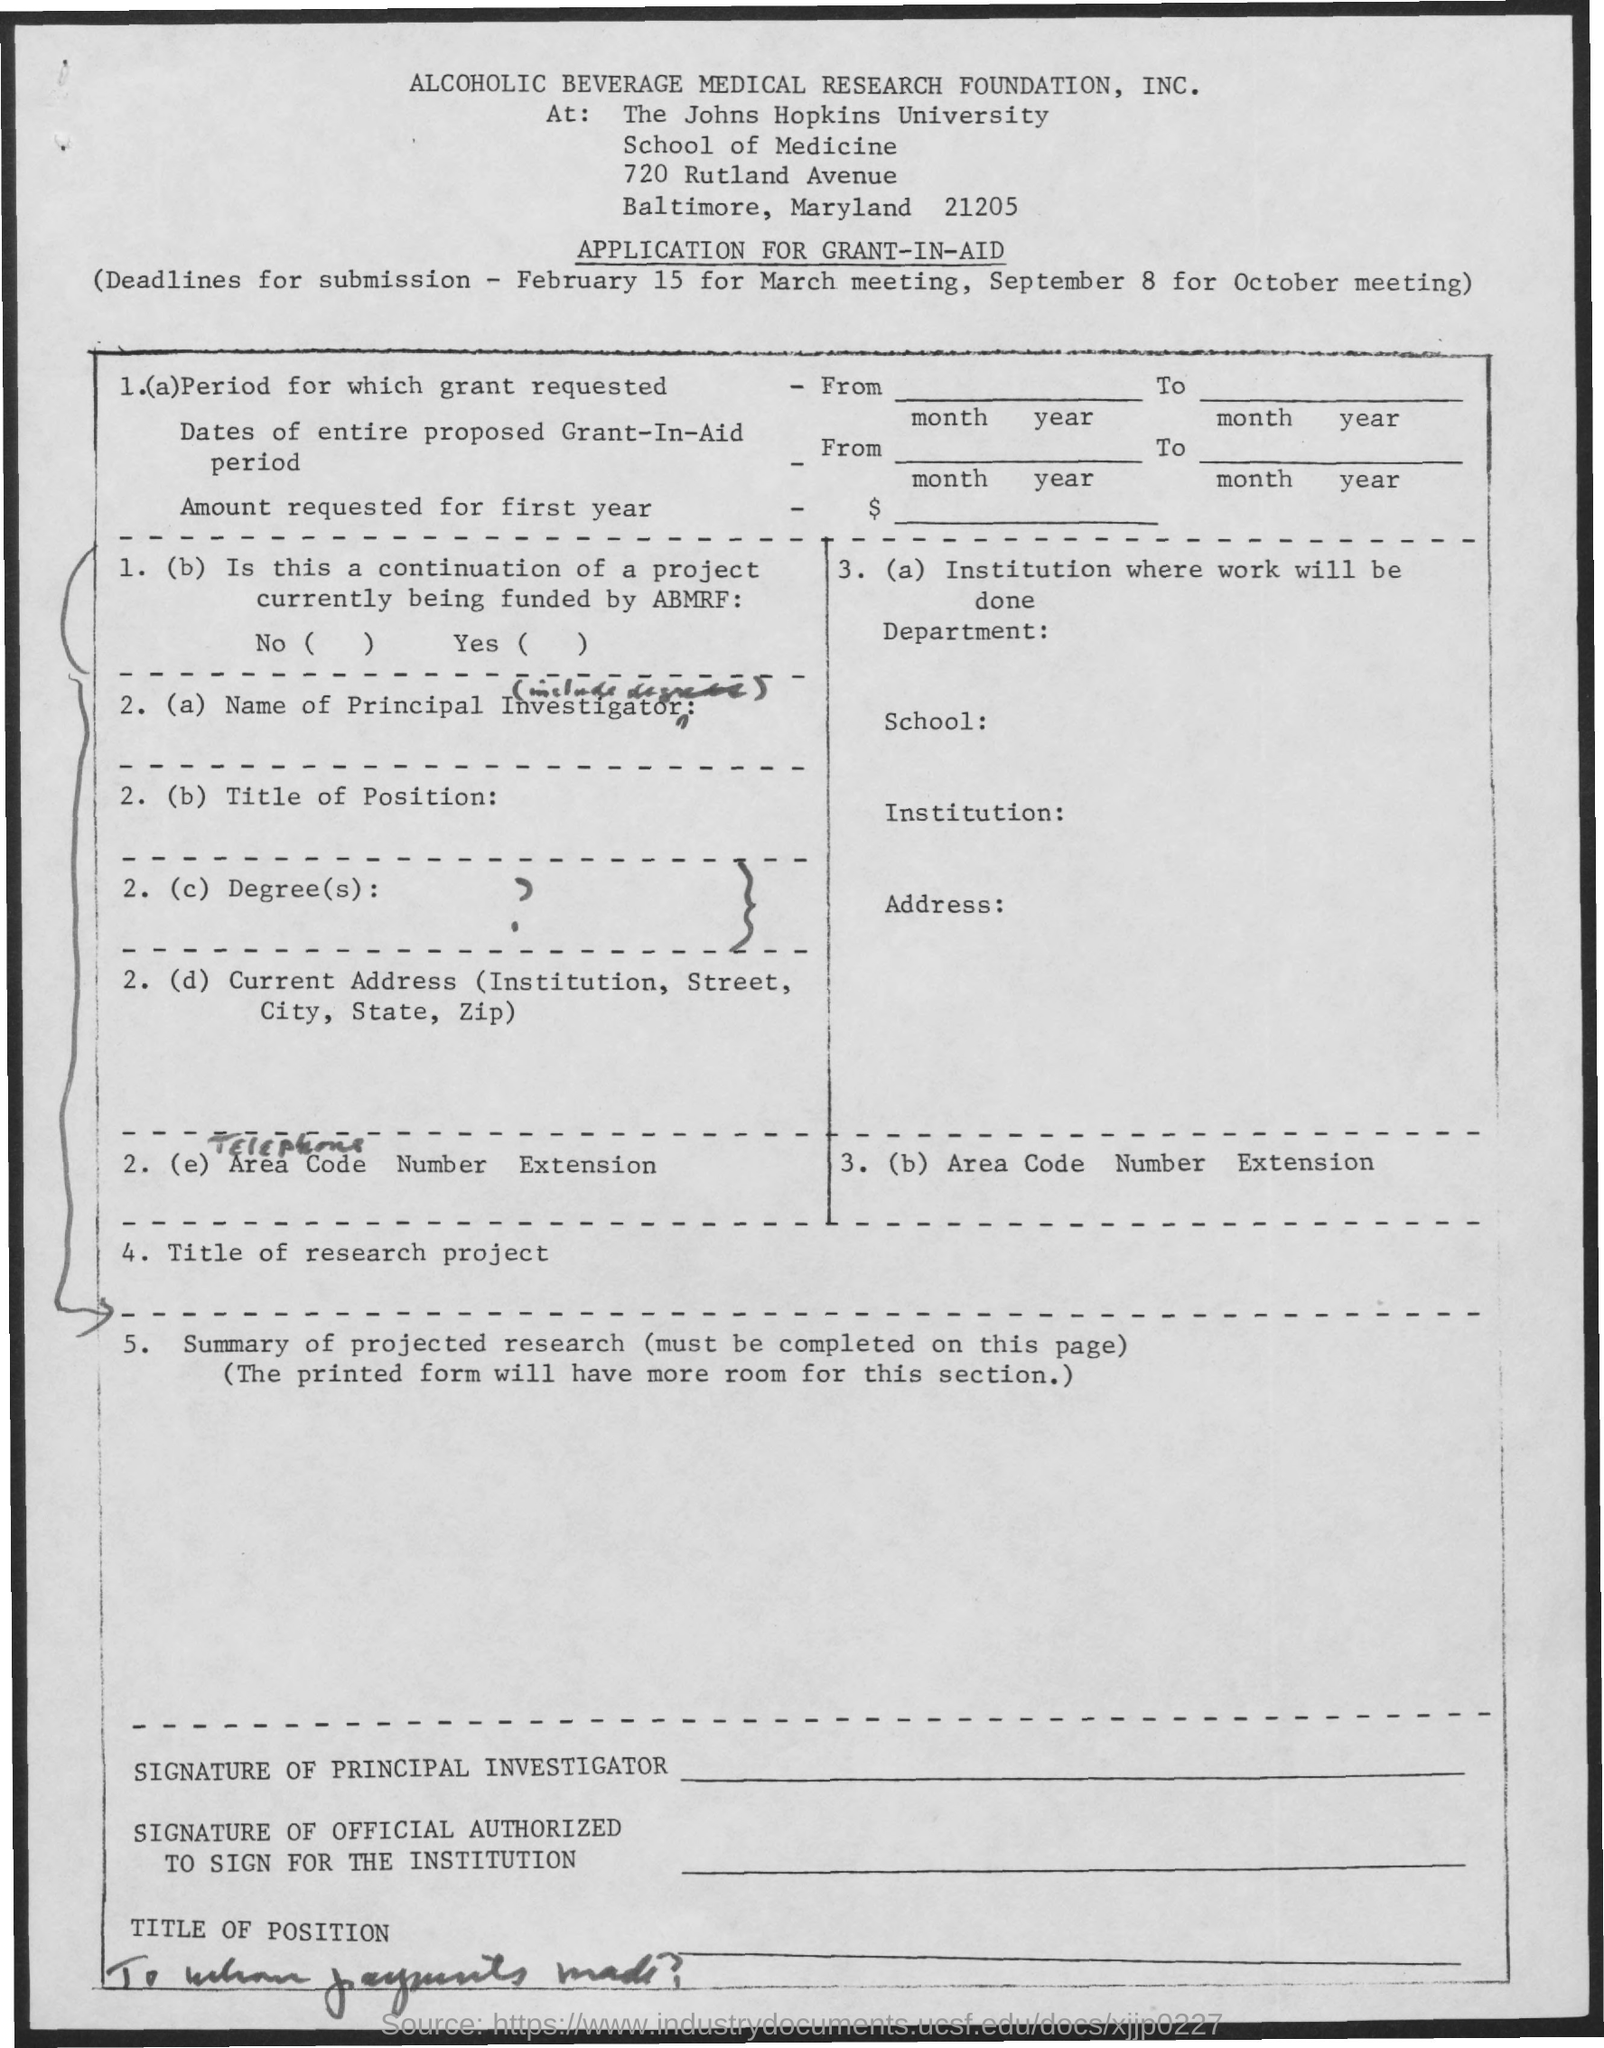What application is this?
Offer a terse response. Application for grant-in-aid. What is the deadline for submission for March meeting?
Your answer should be compact. February 15. What is the deadline for submission for October meeting?
Provide a short and direct response. September 8. 